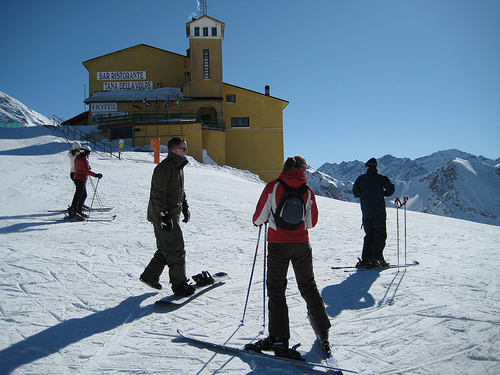Identify the text contained in this image. BAR RISTORANTE TANA HOTEL 